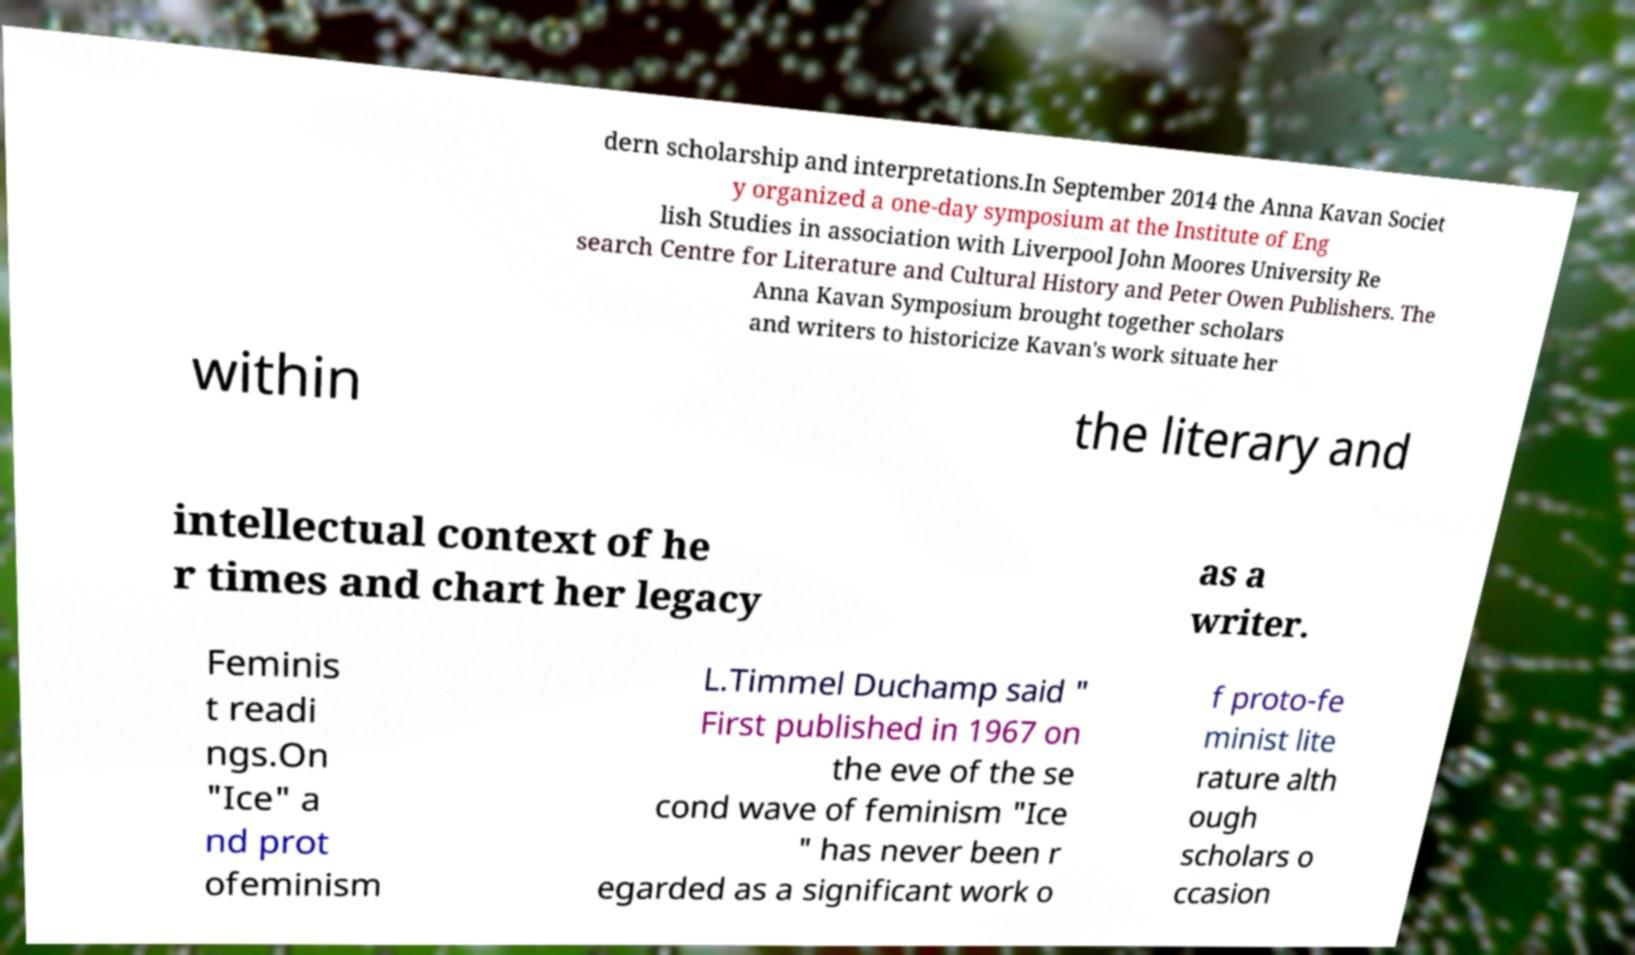Can you read and provide the text displayed in the image?This photo seems to have some interesting text. Can you extract and type it out for me? dern scholarship and interpretations.In September 2014 the Anna Kavan Societ y organized a one-day symposium at the Institute of Eng lish Studies in association with Liverpool John Moores University Re search Centre for Literature and Cultural History and Peter Owen Publishers. The Anna Kavan Symposium brought together scholars and writers to historicize Kavan's work situate her within the literary and intellectual context of he r times and chart her legacy as a writer. Feminis t readi ngs.On "Ice" a nd prot ofeminism L.Timmel Duchamp said " First published in 1967 on the eve of the se cond wave of feminism "Ice " has never been r egarded as a significant work o f proto-fe minist lite rature alth ough scholars o ccasion 